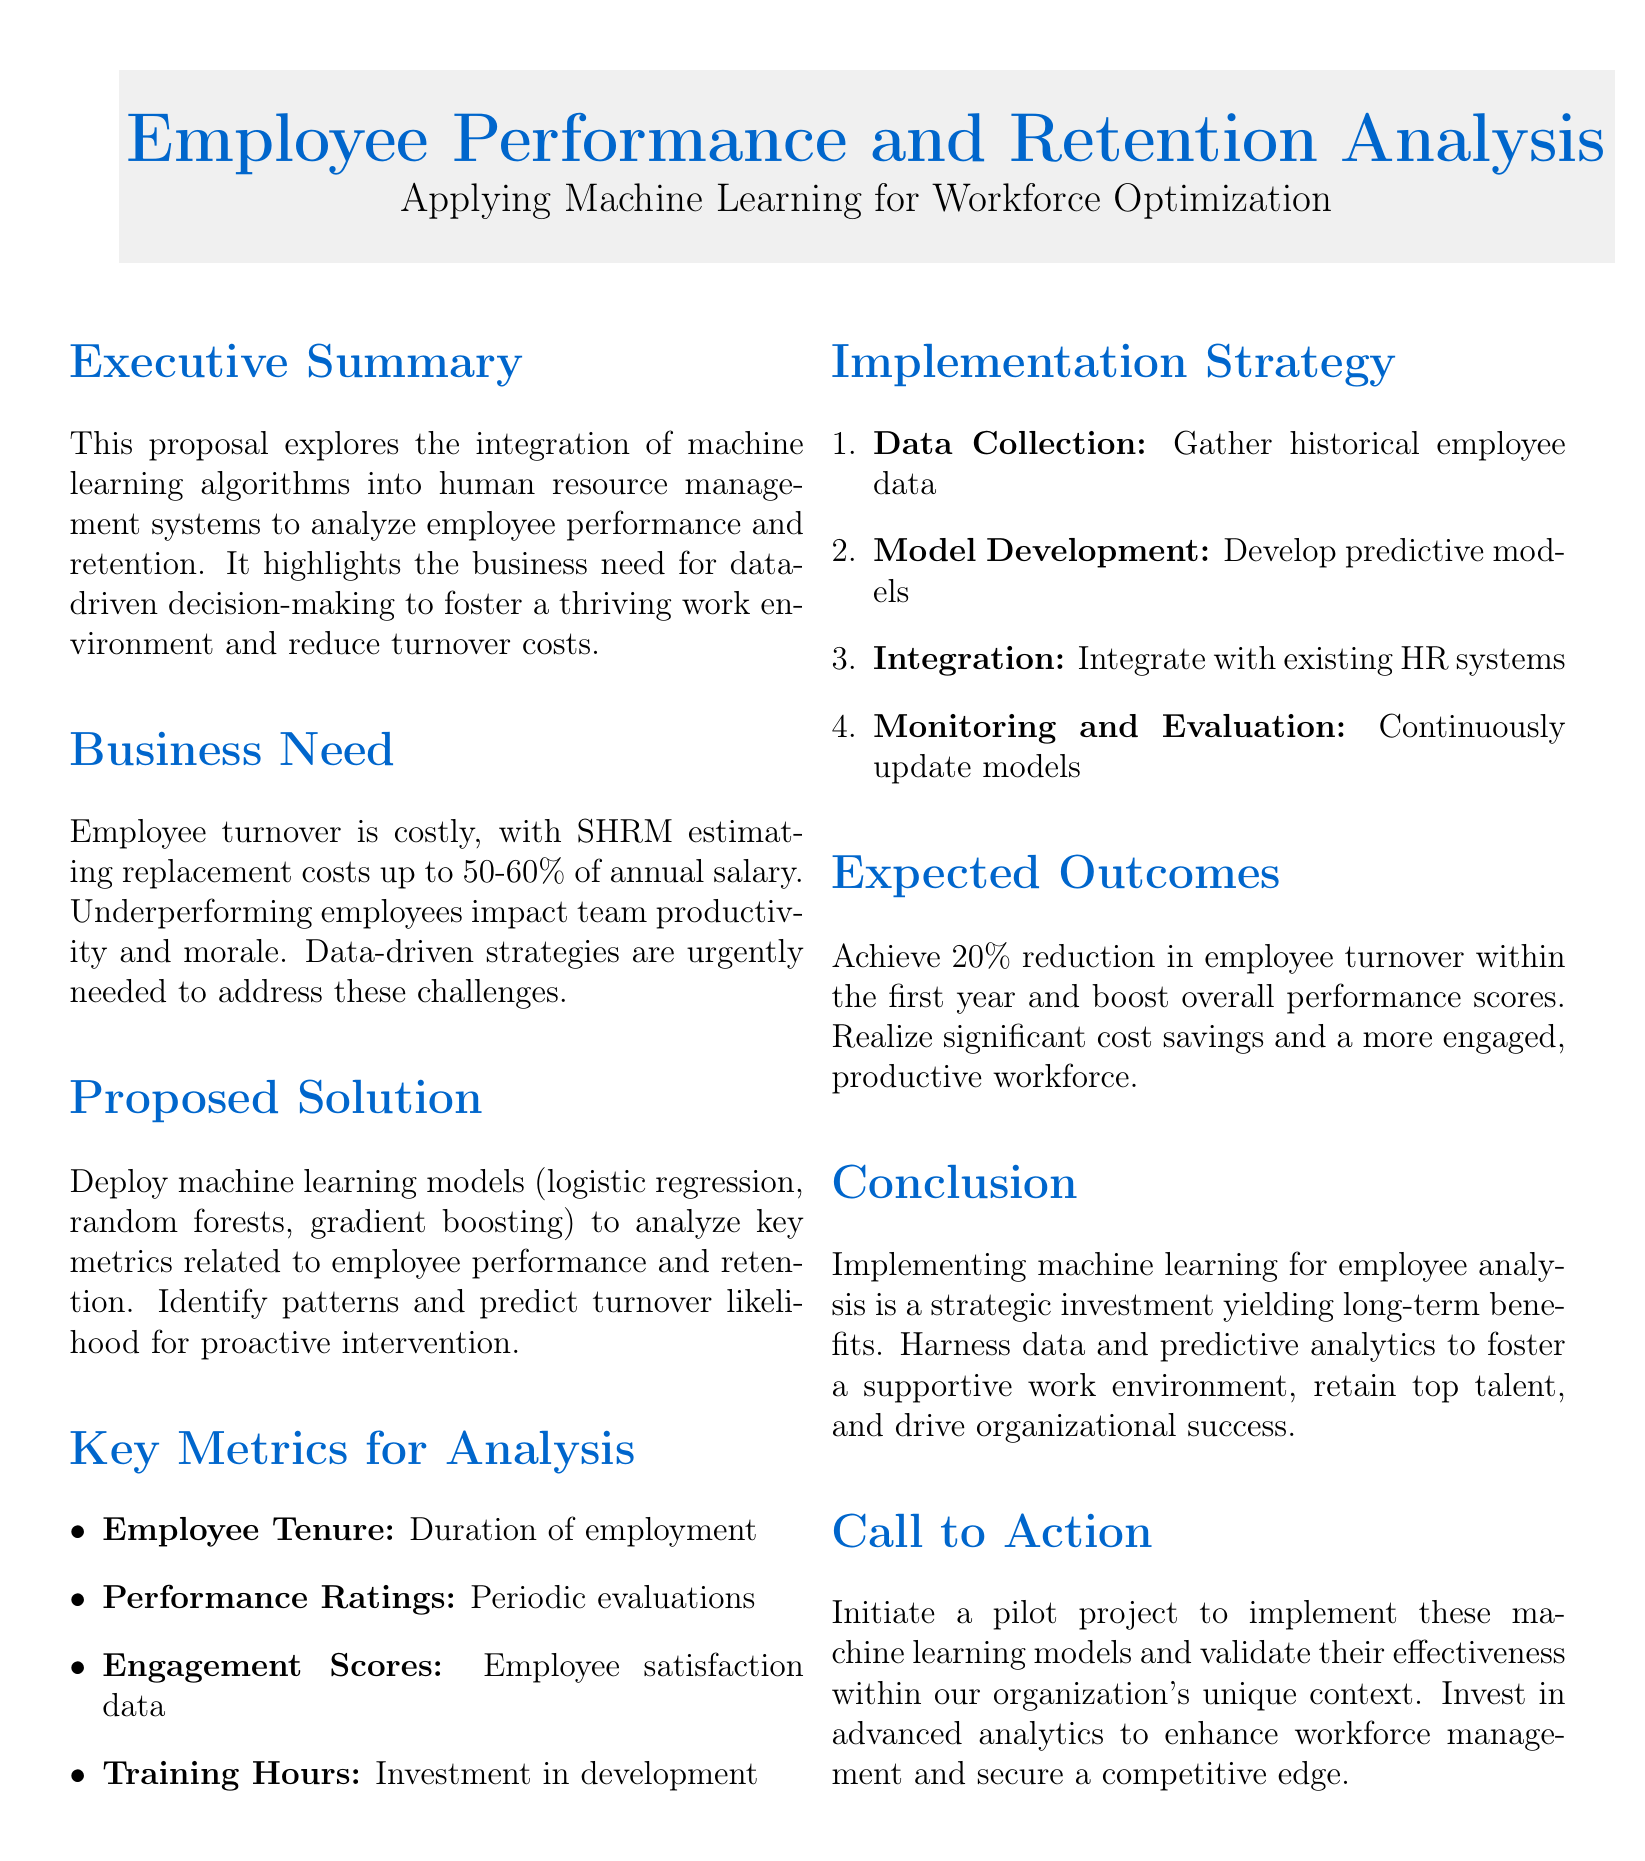What is the primary focus of the proposal? The proposal focuses on the integration of machine learning algorithms into HR management systems for analyzing employee performance and retention.
Answer: Employee Performance and Retention Analysis What is the estimated cost of employee turnover as stated in the document? The document states that SHRM estimates replacement costs of up to 50-60% of annual salary.
Answer: 50-60% What machine learning models are proposed for analysis? The proposal mentions logistic regression, random forests, and gradient boosting as the machine learning models to be used.
Answer: Logistic regression, random forests, gradient boosting What is the expected percentage reduction in employee turnover within the first year? The proposal states an expected outcome of achieving a 20% reduction in employee turnover within the first year.
Answer: 20% Which key metric pertains to employee satisfaction? Engagement Scores are the key metric related to employee satisfaction as stated in the document.
Answer: Engagement Scores What is the first step in the implementation strategy? Data Collection is outlined as the first step in the implementation strategy.
Answer: Data Collection What type of project does the proposal call for to validate the machine learning models? The proposal calls for initiating a pilot project to implement the machine learning models.
Answer: Pilot project What are the anticipated benefits of the proposal? The proposal anticipates long-term benefits such as cost savings and a more engaged workforce.
Answer: Cost savings and engaged workforce 